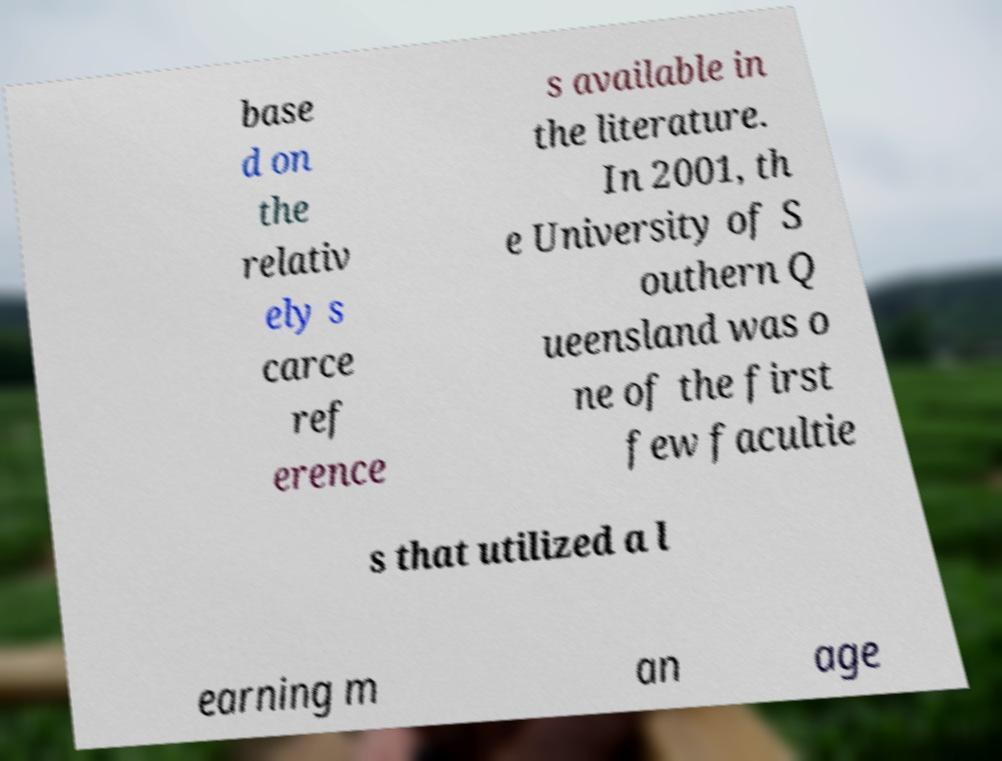Could you assist in decoding the text presented in this image and type it out clearly? base d on the relativ ely s carce ref erence s available in the literature. In 2001, th e University of S outhern Q ueensland was o ne of the first few facultie s that utilized a l earning m an age 